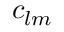<formula> <loc_0><loc_0><loc_500><loc_500>c _ { l m }</formula> 